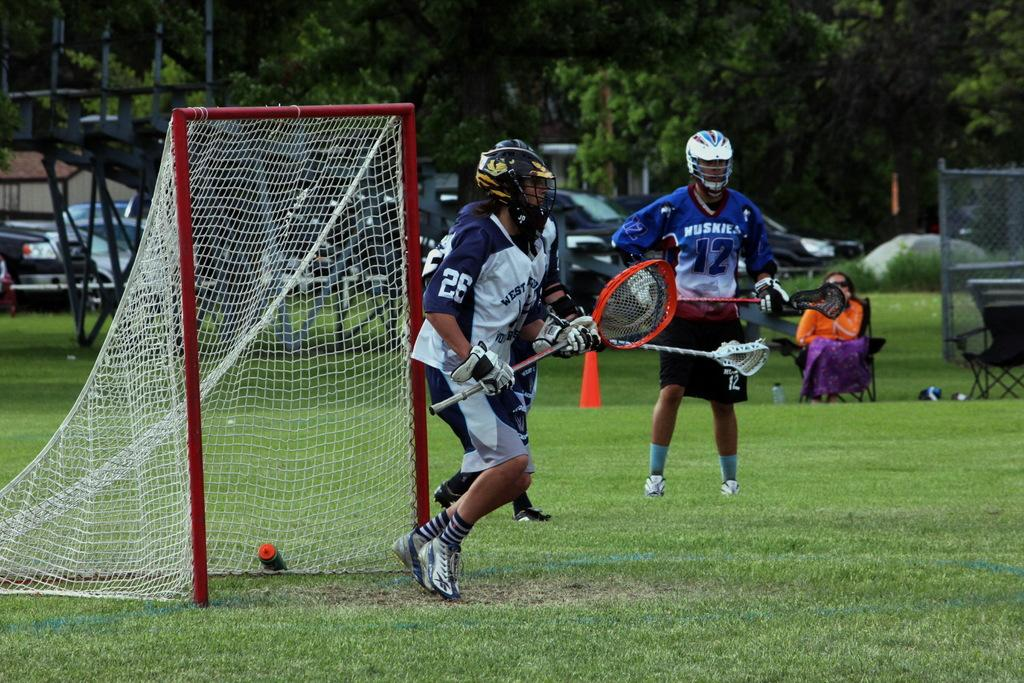<image>
Render a clear and concise summary of the photo. To the left is a man with a shirt with the word Huskies. 